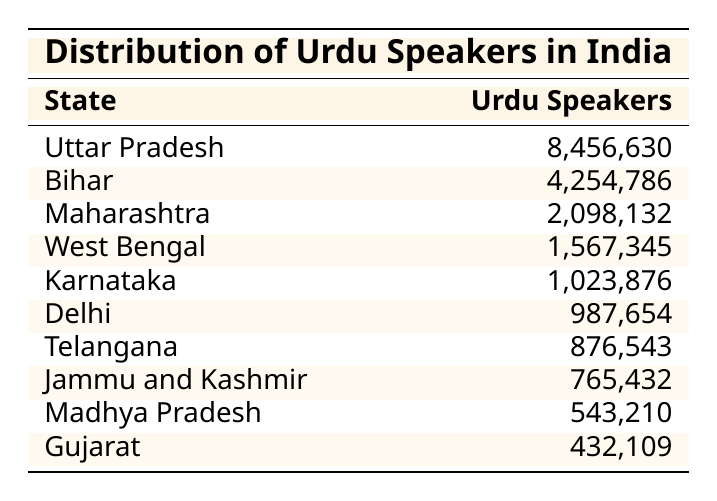What is the total number of Urdu speakers in India based on the table? To find the total number of Urdu speakers, we need to add the numbers of Urdu speakers from all the states listed. The values are: 8456630 (Uttar Pradesh) + 4254786 (Bihar) + 2098132 (Maharashtra) + 1567345 (West Bengal) + 1023876 (Karnataka) + 987654 (Delhi) + 876543 (Telangana) + 765432 (Jammu and Kashmir) + 543210 (Madhya Pradesh) + 432109 (Gujarat) = 14080000.
Answer: 14080000 Which state has the highest number of Urdu speakers? Looking through the table, Uttar Pradesh is listed first with 8456630 Urdu speakers, which is the highest number compared to other states.
Answer: Uttar Pradesh What is the difference in the number of Urdu speakers between Bihar and Karnataka? To find the difference, we subtract the number of Urdu speakers in Karnataka from that in Bihar: 4254786 (Bihar) - 1023876 (Karnataka) = 32309010.
Answer: 32309010 Is the number of Urdu speakers in Telangana greater than that in Gujarat? From the table, Telangana has 876543 Urdu speakers, while Gujarat has 432109. Since 876543 is greater than 432109, the answer is yes.
Answer: Yes What is the average number of Urdu speakers among the listed states? First, we add all the Urdu speakers to get the total (as calculated above, 14080000) and then divide by the number of states (10). Thus, the average is 14080000 / 10 = 1408000.
Answer: 1408000 Which state comes second in the list by the number of Urdu speakers? The second state in the table when sorted by the number of Urdu speakers is Bihar, with 4254786 speakers, as it follows Uttar Pradesh, which has the highest.
Answer: Bihar How many states have more than 1 million Urdu speakers? By examining the table, we see that five states have more than 1 million Urdu speakers: Uttar Pradesh (8,456,630), Bihar (4,254,786), Maharashtra (2,098,132), West Bengal (1,567,345), and Karnataka (1,023,876). Thus, the count is five.
Answer: 5 If we rank the states by the number of Urdu speakers, which state ranks fifth? Looking at the data in order, the states rank as follows: 1) Uttar Pradesh, 2) Bihar, 3) Maharashtra, 4) West Bengal, and 5) Karnataka. Therefore, Karnataka ranks fifth.
Answer: Karnataka What percentage of the total Urdu speakers do the speakers in Delhi represent? First, we take the number of Urdu speakers in Delhi (987654) and divide it by the total (14080000). The percentage is (987654 / 14080000) * 100 = 7.01%.
Answer: 7.01% Is the total number of Urdu speakers in Jammu and Kashmir greater than that in Maharashtra? Jammu and Kashmir has 765432 Urdu speakers, while Maharashtra has 2098132. Since 765432 is less than 2098132, the answer is no.
Answer: No 